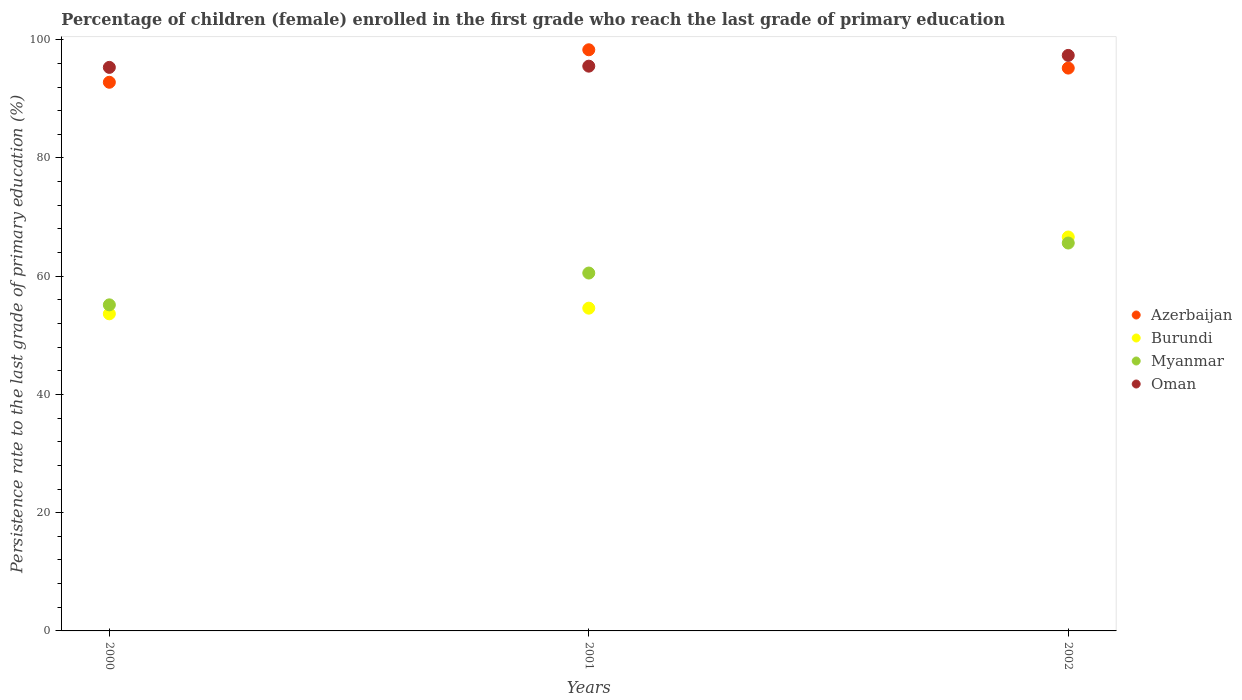How many different coloured dotlines are there?
Keep it short and to the point. 4. Is the number of dotlines equal to the number of legend labels?
Provide a succinct answer. Yes. What is the persistence rate of children in Azerbaijan in 2002?
Give a very brief answer. 95.21. Across all years, what is the maximum persistence rate of children in Burundi?
Make the answer very short. 66.63. Across all years, what is the minimum persistence rate of children in Oman?
Offer a terse response. 95.33. In which year was the persistence rate of children in Azerbaijan maximum?
Offer a terse response. 2001. What is the total persistence rate of children in Oman in the graph?
Your answer should be very brief. 288.21. What is the difference between the persistence rate of children in Myanmar in 2001 and that in 2002?
Keep it short and to the point. -5.08. What is the difference between the persistence rate of children in Oman in 2002 and the persistence rate of children in Myanmar in 2000?
Your answer should be very brief. 42.2. What is the average persistence rate of children in Burundi per year?
Offer a very short reply. 58.29. In the year 2001, what is the difference between the persistence rate of children in Azerbaijan and persistence rate of children in Myanmar?
Provide a succinct answer. 37.77. What is the ratio of the persistence rate of children in Oman in 2000 to that in 2002?
Ensure brevity in your answer.  0.98. What is the difference between the highest and the second highest persistence rate of children in Oman?
Your answer should be very brief. 1.82. What is the difference between the highest and the lowest persistence rate of children in Oman?
Give a very brief answer. 2.03. Is it the case that in every year, the sum of the persistence rate of children in Myanmar and persistence rate of children in Burundi  is greater than the sum of persistence rate of children in Oman and persistence rate of children in Azerbaijan?
Offer a terse response. No. Is the persistence rate of children in Oman strictly less than the persistence rate of children in Azerbaijan over the years?
Your response must be concise. No. How many dotlines are there?
Your response must be concise. 4. How many years are there in the graph?
Give a very brief answer. 3. What is the difference between two consecutive major ticks on the Y-axis?
Provide a succinct answer. 20. Are the values on the major ticks of Y-axis written in scientific E-notation?
Offer a very short reply. No. What is the title of the graph?
Your answer should be compact. Percentage of children (female) enrolled in the first grade who reach the last grade of primary education. What is the label or title of the X-axis?
Your answer should be very brief. Years. What is the label or title of the Y-axis?
Provide a succinct answer. Persistence rate to the last grade of primary education (%). What is the Persistence rate to the last grade of primary education (%) of Azerbaijan in 2000?
Give a very brief answer. 92.81. What is the Persistence rate to the last grade of primary education (%) of Burundi in 2000?
Your answer should be compact. 53.64. What is the Persistence rate to the last grade of primary education (%) of Myanmar in 2000?
Offer a terse response. 55.16. What is the Persistence rate to the last grade of primary education (%) in Oman in 2000?
Make the answer very short. 95.33. What is the Persistence rate to the last grade of primary education (%) in Azerbaijan in 2001?
Your answer should be compact. 98.3. What is the Persistence rate to the last grade of primary education (%) in Burundi in 2001?
Offer a terse response. 54.6. What is the Persistence rate to the last grade of primary education (%) of Myanmar in 2001?
Provide a succinct answer. 60.54. What is the Persistence rate to the last grade of primary education (%) in Oman in 2001?
Give a very brief answer. 95.53. What is the Persistence rate to the last grade of primary education (%) of Azerbaijan in 2002?
Provide a succinct answer. 95.21. What is the Persistence rate to the last grade of primary education (%) of Burundi in 2002?
Make the answer very short. 66.63. What is the Persistence rate to the last grade of primary education (%) of Myanmar in 2002?
Your answer should be very brief. 65.61. What is the Persistence rate to the last grade of primary education (%) in Oman in 2002?
Your answer should be compact. 97.35. Across all years, what is the maximum Persistence rate to the last grade of primary education (%) in Azerbaijan?
Provide a short and direct response. 98.3. Across all years, what is the maximum Persistence rate to the last grade of primary education (%) in Burundi?
Ensure brevity in your answer.  66.63. Across all years, what is the maximum Persistence rate to the last grade of primary education (%) of Myanmar?
Ensure brevity in your answer.  65.61. Across all years, what is the maximum Persistence rate to the last grade of primary education (%) in Oman?
Your answer should be very brief. 97.35. Across all years, what is the minimum Persistence rate to the last grade of primary education (%) in Azerbaijan?
Provide a short and direct response. 92.81. Across all years, what is the minimum Persistence rate to the last grade of primary education (%) of Burundi?
Give a very brief answer. 53.64. Across all years, what is the minimum Persistence rate to the last grade of primary education (%) of Myanmar?
Make the answer very short. 55.16. Across all years, what is the minimum Persistence rate to the last grade of primary education (%) of Oman?
Make the answer very short. 95.33. What is the total Persistence rate to the last grade of primary education (%) of Azerbaijan in the graph?
Your answer should be compact. 286.32. What is the total Persistence rate to the last grade of primary education (%) in Burundi in the graph?
Keep it short and to the point. 174.87. What is the total Persistence rate to the last grade of primary education (%) in Myanmar in the graph?
Give a very brief answer. 181.31. What is the total Persistence rate to the last grade of primary education (%) in Oman in the graph?
Make the answer very short. 288.21. What is the difference between the Persistence rate to the last grade of primary education (%) of Azerbaijan in 2000 and that in 2001?
Make the answer very short. -5.5. What is the difference between the Persistence rate to the last grade of primary education (%) of Burundi in 2000 and that in 2001?
Give a very brief answer. -0.95. What is the difference between the Persistence rate to the last grade of primary education (%) in Myanmar in 2000 and that in 2001?
Offer a terse response. -5.38. What is the difference between the Persistence rate to the last grade of primary education (%) of Oman in 2000 and that in 2001?
Keep it short and to the point. -0.21. What is the difference between the Persistence rate to the last grade of primary education (%) of Azerbaijan in 2000 and that in 2002?
Give a very brief answer. -2.4. What is the difference between the Persistence rate to the last grade of primary education (%) in Burundi in 2000 and that in 2002?
Give a very brief answer. -12.99. What is the difference between the Persistence rate to the last grade of primary education (%) of Myanmar in 2000 and that in 2002?
Ensure brevity in your answer.  -10.46. What is the difference between the Persistence rate to the last grade of primary education (%) of Oman in 2000 and that in 2002?
Your answer should be very brief. -2.03. What is the difference between the Persistence rate to the last grade of primary education (%) in Azerbaijan in 2001 and that in 2002?
Your response must be concise. 3.1. What is the difference between the Persistence rate to the last grade of primary education (%) of Burundi in 2001 and that in 2002?
Offer a terse response. -12.04. What is the difference between the Persistence rate to the last grade of primary education (%) in Myanmar in 2001 and that in 2002?
Give a very brief answer. -5.08. What is the difference between the Persistence rate to the last grade of primary education (%) of Oman in 2001 and that in 2002?
Ensure brevity in your answer.  -1.82. What is the difference between the Persistence rate to the last grade of primary education (%) of Azerbaijan in 2000 and the Persistence rate to the last grade of primary education (%) of Burundi in 2001?
Your response must be concise. 38.21. What is the difference between the Persistence rate to the last grade of primary education (%) in Azerbaijan in 2000 and the Persistence rate to the last grade of primary education (%) in Myanmar in 2001?
Your answer should be compact. 32.27. What is the difference between the Persistence rate to the last grade of primary education (%) of Azerbaijan in 2000 and the Persistence rate to the last grade of primary education (%) of Oman in 2001?
Make the answer very short. -2.72. What is the difference between the Persistence rate to the last grade of primary education (%) of Burundi in 2000 and the Persistence rate to the last grade of primary education (%) of Myanmar in 2001?
Your answer should be compact. -6.9. What is the difference between the Persistence rate to the last grade of primary education (%) of Burundi in 2000 and the Persistence rate to the last grade of primary education (%) of Oman in 2001?
Give a very brief answer. -41.89. What is the difference between the Persistence rate to the last grade of primary education (%) in Myanmar in 2000 and the Persistence rate to the last grade of primary education (%) in Oman in 2001?
Keep it short and to the point. -40.38. What is the difference between the Persistence rate to the last grade of primary education (%) of Azerbaijan in 2000 and the Persistence rate to the last grade of primary education (%) of Burundi in 2002?
Your response must be concise. 26.18. What is the difference between the Persistence rate to the last grade of primary education (%) of Azerbaijan in 2000 and the Persistence rate to the last grade of primary education (%) of Myanmar in 2002?
Offer a very short reply. 27.19. What is the difference between the Persistence rate to the last grade of primary education (%) of Azerbaijan in 2000 and the Persistence rate to the last grade of primary education (%) of Oman in 2002?
Give a very brief answer. -4.54. What is the difference between the Persistence rate to the last grade of primary education (%) of Burundi in 2000 and the Persistence rate to the last grade of primary education (%) of Myanmar in 2002?
Your response must be concise. -11.97. What is the difference between the Persistence rate to the last grade of primary education (%) of Burundi in 2000 and the Persistence rate to the last grade of primary education (%) of Oman in 2002?
Offer a terse response. -43.71. What is the difference between the Persistence rate to the last grade of primary education (%) in Myanmar in 2000 and the Persistence rate to the last grade of primary education (%) in Oman in 2002?
Your answer should be very brief. -42.2. What is the difference between the Persistence rate to the last grade of primary education (%) in Azerbaijan in 2001 and the Persistence rate to the last grade of primary education (%) in Burundi in 2002?
Your response must be concise. 31.67. What is the difference between the Persistence rate to the last grade of primary education (%) in Azerbaijan in 2001 and the Persistence rate to the last grade of primary education (%) in Myanmar in 2002?
Make the answer very short. 32.69. What is the difference between the Persistence rate to the last grade of primary education (%) of Azerbaijan in 2001 and the Persistence rate to the last grade of primary education (%) of Oman in 2002?
Provide a succinct answer. 0.95. What is the difference between the Persistence rate to the last grade of primary education (%) of Burundi in 2001 and the Persistence rate to the last grade of primary education (%) of Myanmar in 2002?
Keep it short and to the point. -11.02. What is the difference between the Persistence rate to the last grade of primary education (%) of Burundi in 2001 and the Persistence rate to the last grade of primary education (%) of Oman in 2002?
Keep it short and to the point. -42.76. What is the difference between the Persistence rate to the last grade of primary education (%) in Myanmar in 2001 and the Persistence rate to the last grade of primary education (%) in Oman in 2002?
Provide a short and direct response. -36.81. What is the average Persistence rate to the last grade of primary education (%) in Azerbaijan per year?
Your response must be concise. 95.44. What is the average Persistence rate to the last grade of primary education (%) in Burundi per year?
Your answer should be compact. 58.29. What is the average Persistence rate to the last grade of primary education (%) of Myanmar per year?
Ensure brevity in your answer.  60.44. What is the average Persistence rate to the last grade of primary education (%) of Oman per year?
Your response must be concise. 96.07. In the year 2000, what is the difference between the Persistence rate to the last grade of primary education (%) of Azerbaijan and Persistence rate to the last grade of primary education (%) of Burundi?
Provide a succinct answer. 39.17. In the year 2000, what is the difference between the Persistence rate to the last grade of primary education (%) in Azerbaijan and Persistence rate to the last grade of primary education (%) in Myanmar?
Provide a succinct answer. 37.65. In the year 2000, what is the difference between the Persistence rate to the last grade of primary education (%) in Azerbaijan and Persistence rate to the last grade of primary education (%) in Oman?
Offer a terse response. -2.52. In the year 2000, what is the difference between the Persistence rate to the last grade of primary education (%) of Burundi and Persistence rate to the last grade of primary education (%) of Myanmar?
Offer a very short reply. -1.52. In the year 2000, what is the difference between the Persistence rate to the last grade of primary education (%) in Burundi and Persistence rate to the last grade of primary education (%) in Oman?
Give a very brief answer. -41.69. In the year 2000, what is the difference between the Persistence rate to the last grade of primary education (%) in Myanmar and Persistence rate to the last grade of primary education (%) in Oman?
Your response must be concise. -40.17. In the year 2001, what is the difference between the Persistence rate to the last grade of primary education (%) in Azerbaijan and Persistence rate to the last grade of primary education (%) in Burundi?
Make the answer very short. 43.71. In the year 2001, what is the difference between the Persistence rate to the last grade of primary education (%) of Azerbaijan and Persistence rate to the last grade of primary education (%) of Myanmar?
Your response must be concise. 37.77. In the year 2001, what is the difference between the Persistence rate to the last grade of primary education (%) in Azerbaijan and Persistence rate to the last grade of primary education (%) in Oman?
Offer a very short reply. 2.77. In the year 2001, what is the difference between the Persistence rate to the last grade of primary education (%) of Burundi and Persistence rate to the last grade of primary education (%) of Myanmar?
Keep it short and to the point. -5.94. In the year 2001, what is the difference between the Persistence rate to the last grade of primary education (%) of Burundi and Persistence rate to the last grade of primary education (%) of Oman?
Your answer should be very brief. -40.94. In the year 2001, what is the difference between the Persistence rate to the last grade of primary education (%) in Myanmar and Persistence rate to the last grade of primary education (%) in Oman?
Make the answer very short. -34.99. In the year 2002, what is the difference between the Persistence rate to the last grade of primary education (%) in Azerbaijan and Persistence rate to the last grade of primary education (%) in Burundi?
Offer a very short reply. 28.57. In the year 2002, what is the difference between the Persistence rate to the last grade of primary education (%) in Azerbaijan and Persistence rate to the last grade of primary education (%) in Myanmar?
Offer a terse response. 29.59. In the year 2002, what is the difference between the Persistence rate to the last grade of primary education (%) of Azerbaijan and Persistence rate to the last grade of primary education (%) of Oman?
Provide a short and direct response. -2.14. In the year 2002, what is the difference between the Persistence rate to the last grade of primary education (%) of Burundi and Persistence rate to the last grade of primary education (%) of Myanmar?
Provide a succinct answer. 1.02. In the year 2002, what is the difference between the Persistence rate to the last grade of primary education (%) in Burundi and Persistence rate to the last grade of primary education (%) in Oman?
Keep it short and to the point. -30.72. In the year 2002, what is the difference between the Persistence rate to the last grade of primary education (%) in Myanmar and Persistence rate to the last grade of primary education (%) in Oman?
Your response must be concise. -31.74. What is the ratio of the Persistence rate to the last grade of primary education (%) in Azerbaijan in 2000 to that in 2001?
Make the answer very short. 0.94. What is the ratio of the Persistence rate to the last grade of primary education (%) in Burundi in 2000 to that in 2001?
Give a very brief answer. 0.98. What is the ratio of the Persistence rate to the last grade of primary education (%) in Myanmar in 2000 to that in 2001?
Your response must be concise. 0.91. What is the ratio of the Persistence rate to the last grade of primary education (%) of Oman in 2000 to that in 2001?
Provide a succinct answer. 1. What is the ratio of the Persistence rate to the last grade of primary education (%) in Azerbaijan in 2000 to that in 2002?
Your answer should be compact. 0.97. What is the ratio of the Persistence rate to the last grade of primary education (%) of Burundi in 2000 to that in 2002?
Make the answer very short. 0.81. What is the ratio of the Persistence rate to the last grade of primary education (%) in Myanmar in 2000 to that in 2002?
Your answer should be very brief. 0.84. What is the ratio of the Persistence rate to the last grade of primary education (%) of Oman in 2000 to that in 2002?
Make the answer very short. 0.98. What is the ratio of the Persistence rate to the last grade of primary education (%) in Azerbaijan in 2001 to that in 2002?
Ensure brevity in your answer.  1.03. What is the ratio of the Persistence rate to the last grade of primary education (%) in Burundi in 2001 to that in 2002?
Your answer should be very brief. 0.82. What is the ratio of the Persistence rate to the last grade of primary education (%) of Myanmar in 2001 to that in 2002?
Offer a very short reply. 0.92. What is the ratio of the Persistence rate to the last grade of primary education (%) of Oman in 2001 to that in 2002?
Offer a very short reply. 0.98. What is the difference between the highest and the second highest Persistence rate to the last grade of primary education (%) in Azerbaijan?
Your answer should be very brief. 3.1. What is the difference between the highest and the second highest Persistence rate to the last grade of primary education (%) of Burundi?
Your answer should be very brief. 12.04. What is the difference between the highest and the second highest Persistence rate to the last grade of primary education (%) of Myanmar?
Make the answer very short. 5.08. What is the difference between the highest and the second highest Persistence rate to the last grade of primary education (%) of Oman?
Offer a terse response. 1.82. What is the difference between the highest and the lowest Persistence rate to the last grade of primary education (%) in Azerbaijan?
Offer a very short reply. 5.5. What is the difference between the highest and the lowest Persistence rate to the last grade of primary education (%) in Burundi?
Offer a very short reply. 12.99. What is the difference between the highest and the lowest Persistence rate to the last grade of primary education (%) in Myanmar?
Your answer should be compact. 10.46. What is the difference between the highest and the lowest Persistence rate to the last grade of primary education (%) of Oman?
Make the answer very short. 2.03. 